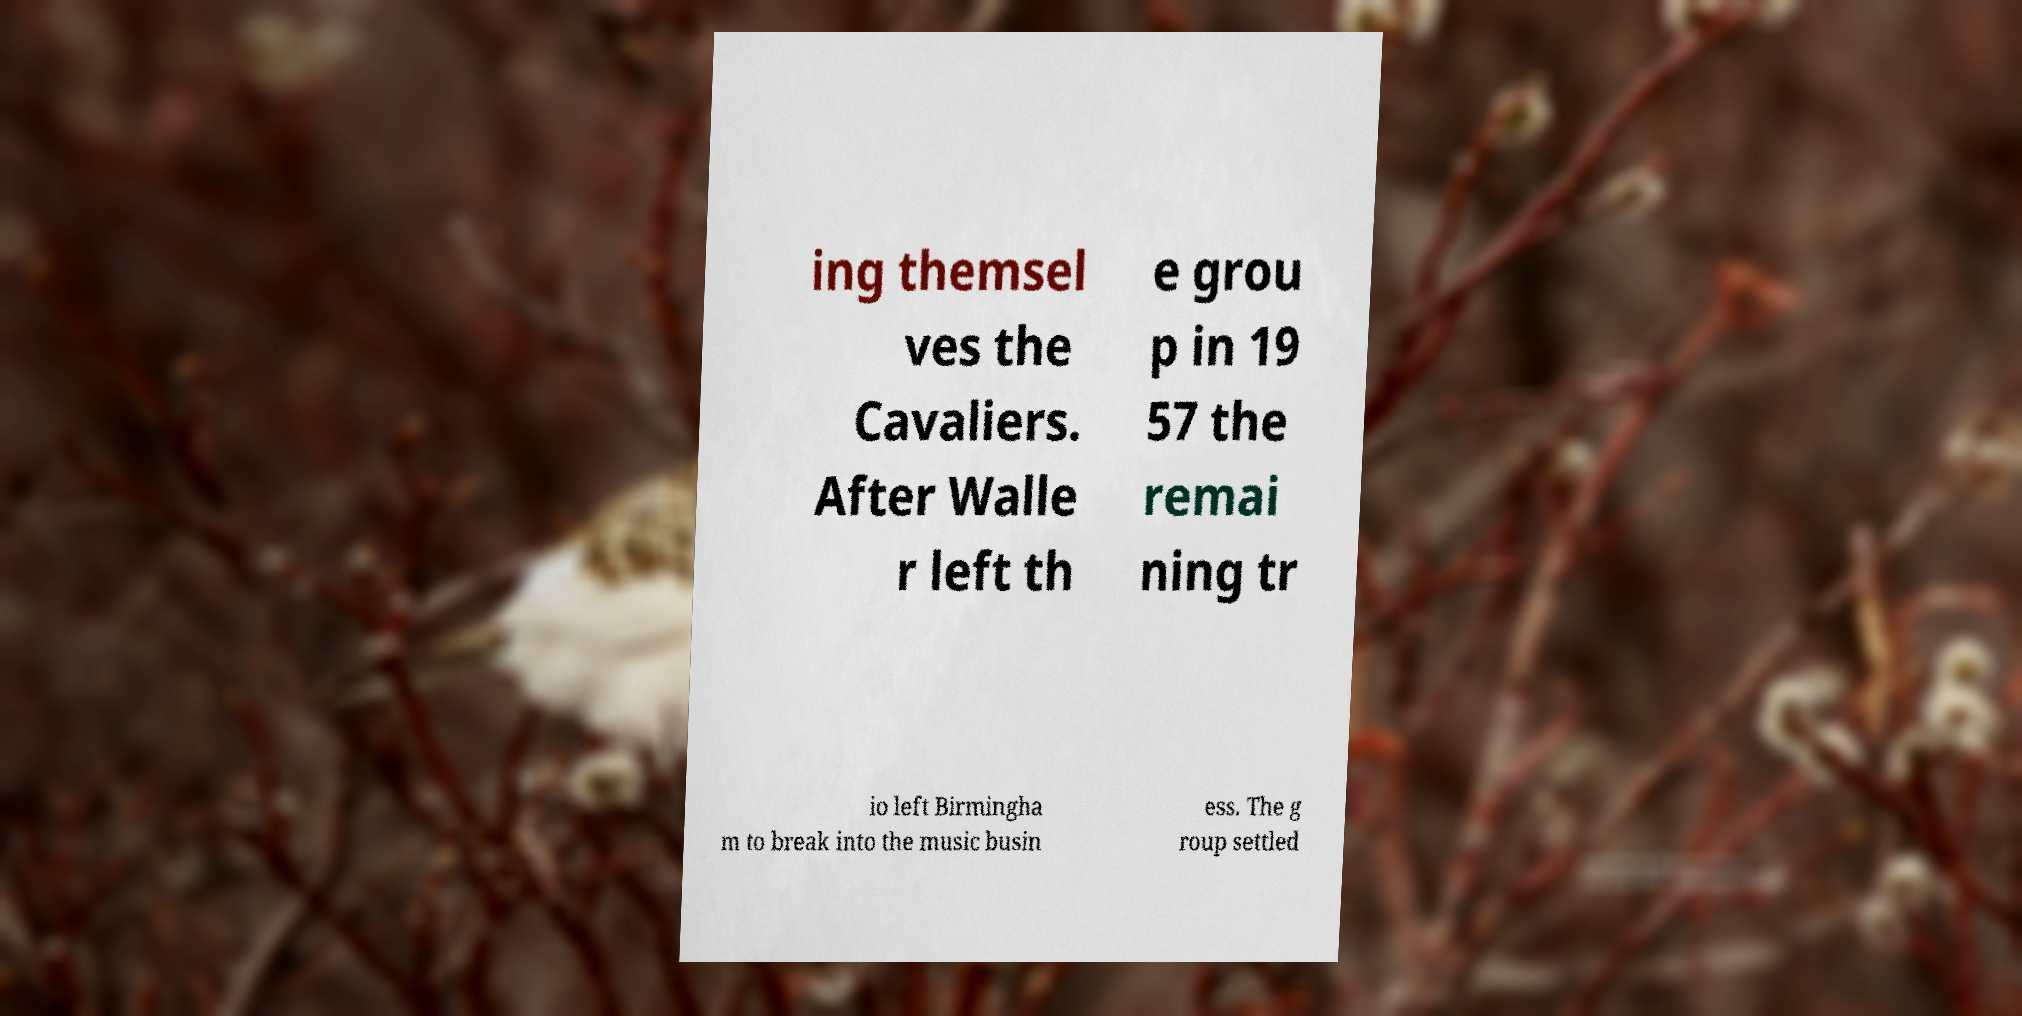Please identify and transcribe the text found in this image. ing themsel ves the Cavaliers. After Walle r left th e grou p in 19 57 the remai ning tr io left Birmingha m to break into the music busin ess. The g roup settled 